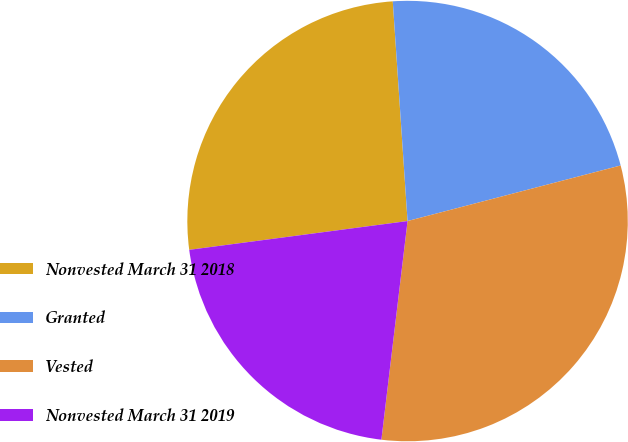Convert chart. <chart><loc_0><loc_0><loc_500><loc_500><pie_chart><fcel>Nonvested March 31 2018<fcel>Granted<fcel>Vested<fcel>Nonvested March 31 2019<nl><fcel>26.02%<fcel>22.01%<fcel>30.96%<fcel>21.02%<nl></chart> 